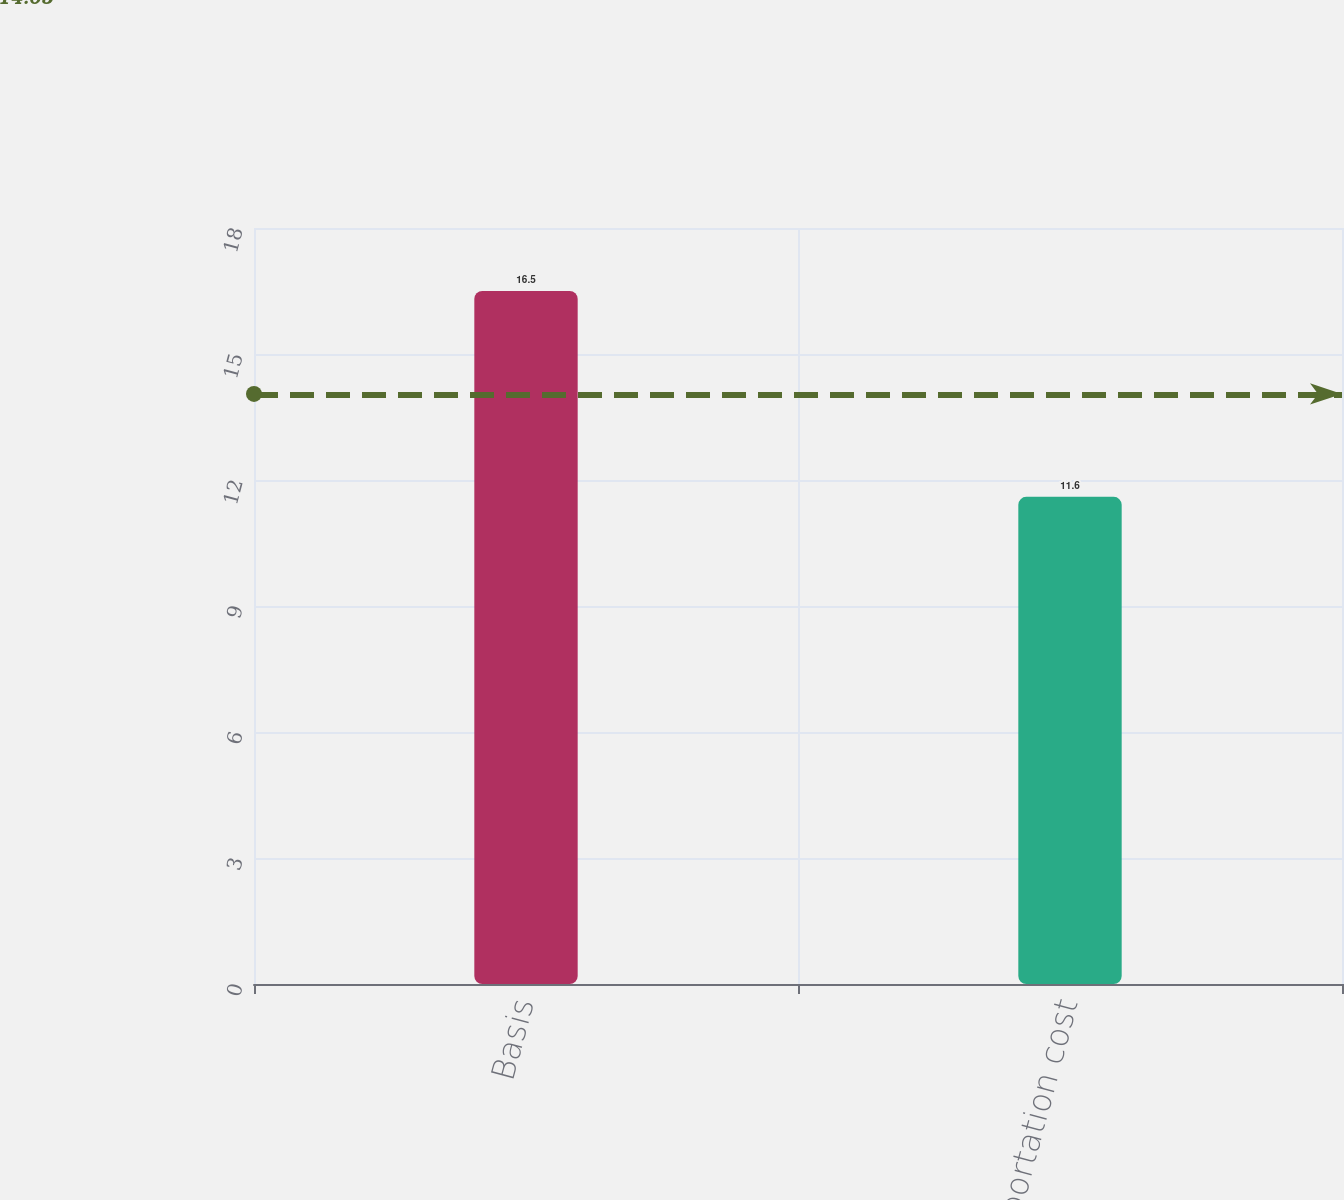<chart> <loc_0><loc_0><loc_500><loc_500><bar_chart><fcel>Basis<fcel>Transportation cost<nl><fcel>16.5<fcel>11.6<nl></chart> 